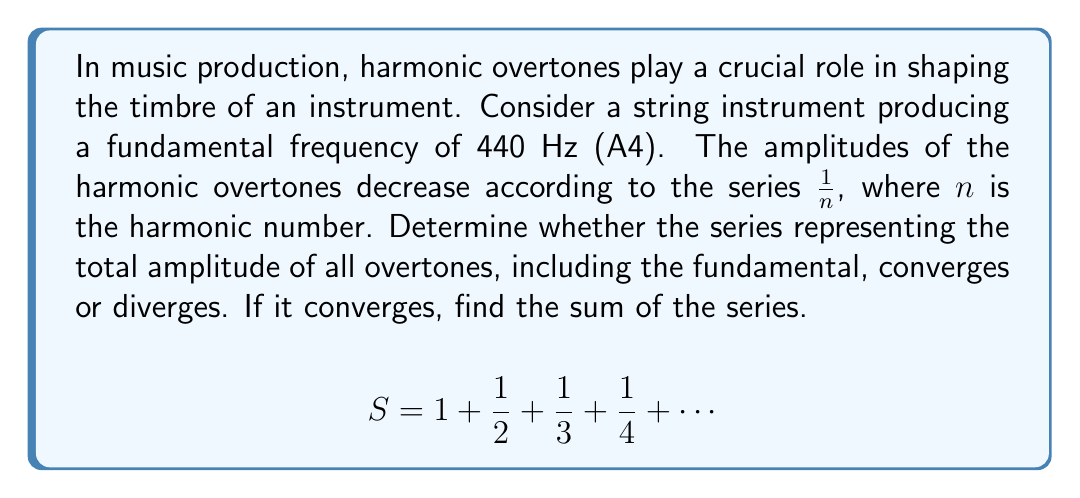Teach me how to tackle this problem. To analyze the convergence of this series, we can use the following steps:

1) Recognize the series:
   This is the harmonic series, which is a well-known divergent series.

2) Prove divergence:
   We can use the comparison test to prove that this series diverges.
   
   Let's group the terms as follows:
   $$S = 1 + (\frac{1}{2}) + (\frac{1}{3} + \frac{1}{4}) + (\frac{1}{5} + \frac{1}{6} + \frac{1}{7} + \frac{1}{8}) + \cdots$$
   
   Now, let's compare each group with $\frac{1}{2}$:
   $$S > 1 + \frac{1}{2} + (\frac{1}{4} + \frac{1}{4}) + (\frac{1}{8} + \frac{1}{8} + \frac{1}{8} + \frac{1}{8}) + \cdots$$
   $$S > 1 + \frac{1}{2} + \frac{1}{2} + \frac{1}{2} + \cdots$$

   This new series clearly diverges, as it's an infinite sum of $\frac{1}{2}$. Since our original series is greater than a divergent series, it must also diverge.

3) Musical interpretation:
   In the context of musical overtones, this divergence implies that if we could theoretically produce an infinite number of overtones with amplitudes decreasing as $\frac{1}{n}$, the total amplitude would be infinite. In practice, however, the number of overtones is finite, and their amplitudes often decrease more rapidly than $\frac{1}{n}$, allowing for a finite total amplitude.
Answer: The series diverges. There is no finite sum. 